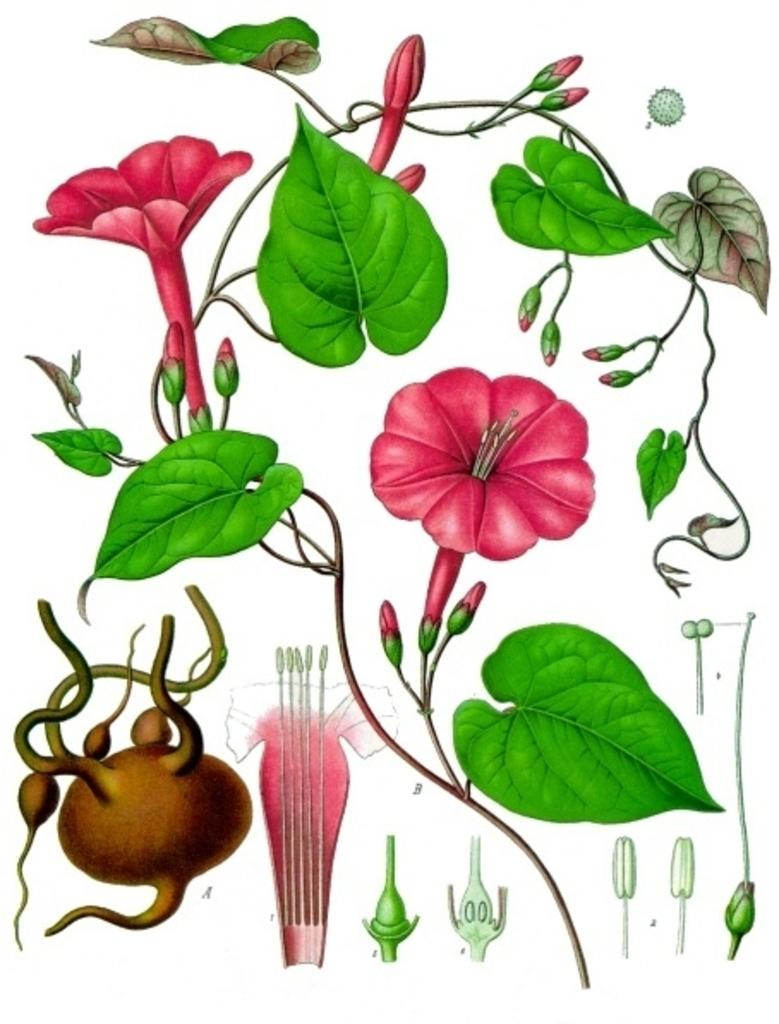What type of plants can be seen in the image? There are flowers and green leaves in the image. Can you describe the color of the flowers? The provided facts do not specify the color of the flowers. What is the color of the leaves in the image? The leaves in the image are green. What type of guide can be seen leading a group of people through the arch in the image? There is no guide or arch present in the image; it only features flowers and green leaves. How many volleyballs are visible in the image? There are no volleyballs present in the image. 